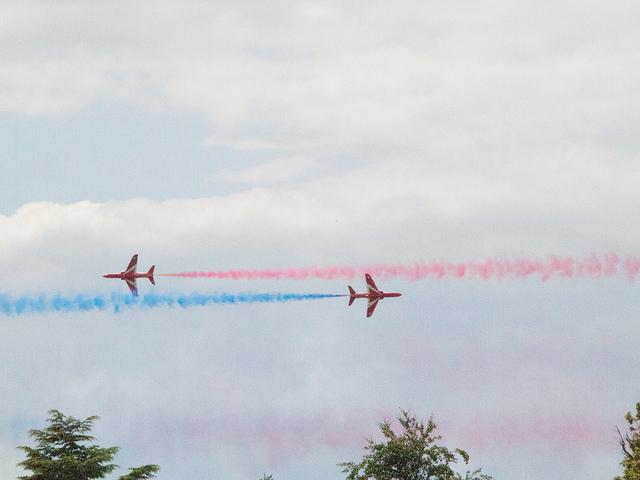Do you see any popsicle sticks?
Write a very short answer. No. What is in the air?
Write a very short answer. Planes. Is this air show likely for an advertisement?
Quick response, please. No. What trail color is masculine?
Concise answer only. Blue. Is this entertaining?
Answer briefly. Yes. Is this in the Amazon?
Short answer required. No. 